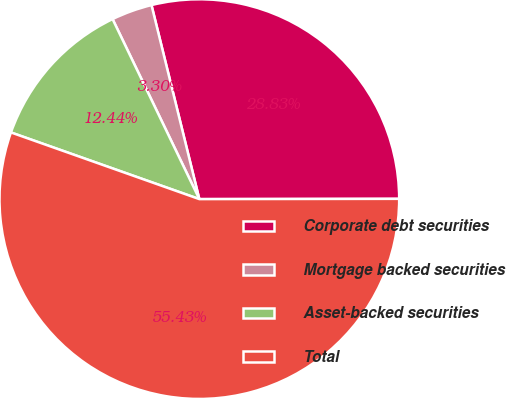<chart> <loc_0><loc_0><loc_500><loc_500><pie_chart><fcel>Corporate debt securities<fcel>Mortgage backed securities<fcel>Asset-backed securities<fcel>Total<nl><fcel>28.83%<fcel>3.3%<fcel>12.44%<fcel>55.44%<nl></chart> 